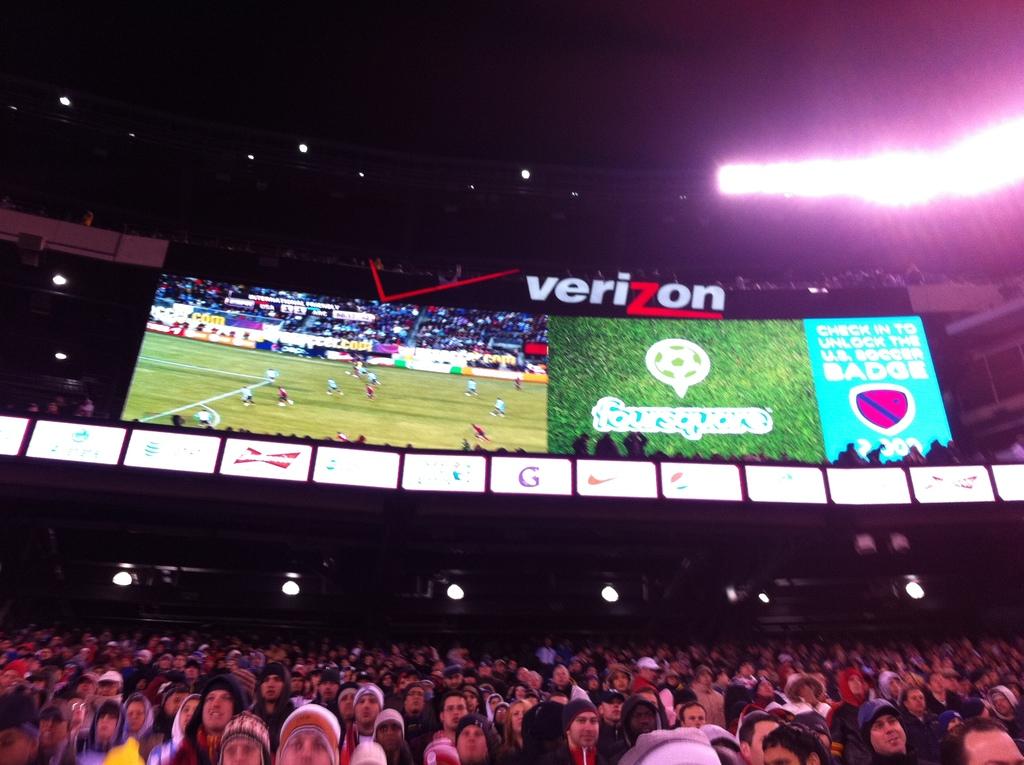Is the stadium named after verizon?
Provide a short and direct response. Yes. Is the location of the venue sponsored by verizon?
Ensure brevity in your answer.  Yes. 